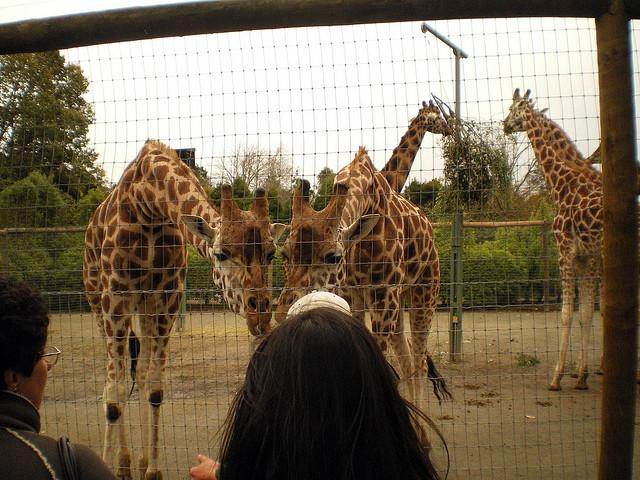What is the person on the left wearing? glasses 